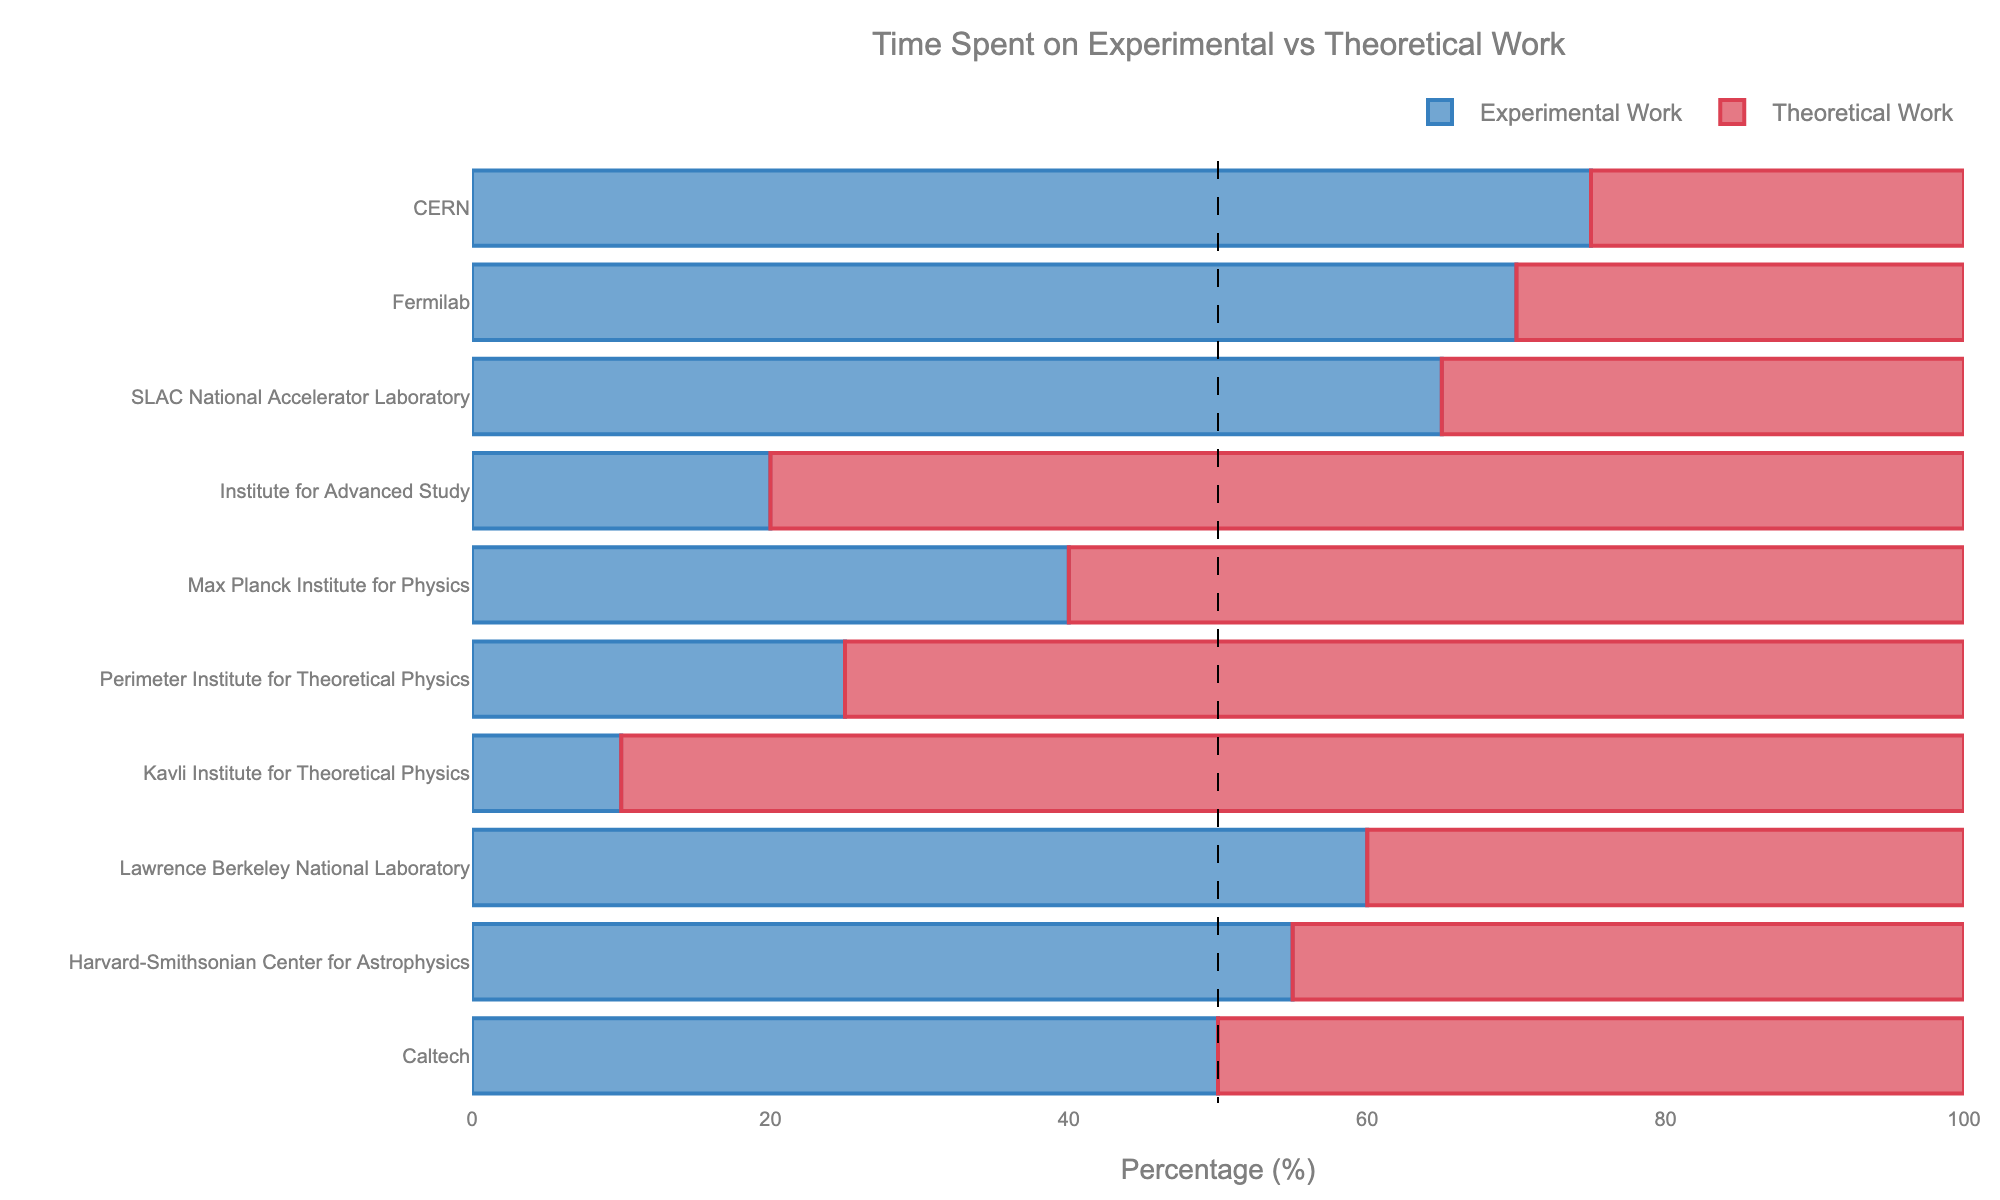Which institution spends the highest percentage of time on experimental work? To find the institution that spends the highest percentage of time on experimental work, we need to look for the longest blue bar (experimental work) in the chart. According to the data, CERN has the highest value at 75%.
Answer: CERN Which institution spends the highest percentage of time on theoretical work? To identify the institution with the highest percentage of time on theoretical work, we need to find the longest red bar (theoretical work) in the chart. The Kavli Institute for Theoretical Physics has the highest value at 90%.
Answer: Kavli Institute for Theoretical Physics What is the difference in the percentage of time spent on experimental work between CERN and Fermilab? To calculate the difference, find the percentage values for experimental work for both institutions and subtract the smaller value from the larger one. For CERN, it is 75%, and for Fermilab, it is 70%. The difference is 75% - 70% = 5%.
Answer: 5% Which institution shows an equal distribution of time spent on experimental and theoretical work? To find the institution with an equal distribution, look for the bar where both blue and red sections are of equal length. Caltech has equal distribution with 50% experimental work and 50% theoretical work.
Answer: Caltech How much more time does the Max Planck Institute for Physics spend on theoretical work compared to experimental work? To find this, subtract the percentage of time spent on experimental work from theoretical work for the Max Planck Institute for Physics. Theoretical is 60%, and experimental is 40%. The difference is 60% - 40% = 20%.
Answer: 20% Among the listed institutions, which one focuses more on experimental work than theoretical work but has less than 50% focus on theoretical work? We need to find institutions where the percentage of experimental work is higher than theoretical work but theoretical work is less than 50%. Lawrence Berkeley National Laboratory spends 60% on experimental work and 40% on theoretical work, fitting these criteria.
Answer: Lawrence Berkeley National Laboratory What is the combined percentage of theoretical work for the Institutes: CERN, Fermilab, and SLAC National Accelerator Laboratory? Add the theoretical work percentages for these three institutions. For CERN, it’s 25%, for Fermilab, it’s 30%, and for SLAC, it’s 35%. The combined percentage is 25% + 30% + 35% = 90%.
Answer: 90% If you sum the time spent on experimental work for Harvard-Smithsonian Center for Astrophysics and Max Planck Institute for Physics, do they spend more or less total time than CERN on experimental work? Add the experimental work percentages for Harvard-Smithsonian Center for Astrophysics (55%) and Max Planck Institute for Physics (40%). The total is 55% + 40% = 95%. Compare this with CERN's 75%. They spend more (95% vs 75%).
Answer: More What is the average percentage of theoretical work across all institutions? Sum the theoretical work percentages of all institutions and divide by the number of institutions. The percentages are 25%, 30%, 35%, 80%, 60%, 75%, 90%, 40%, 45%, and 50%. The total is 530%. Divide 530% by 10 institutions, getting an average of 53%.
Answer: 53% 